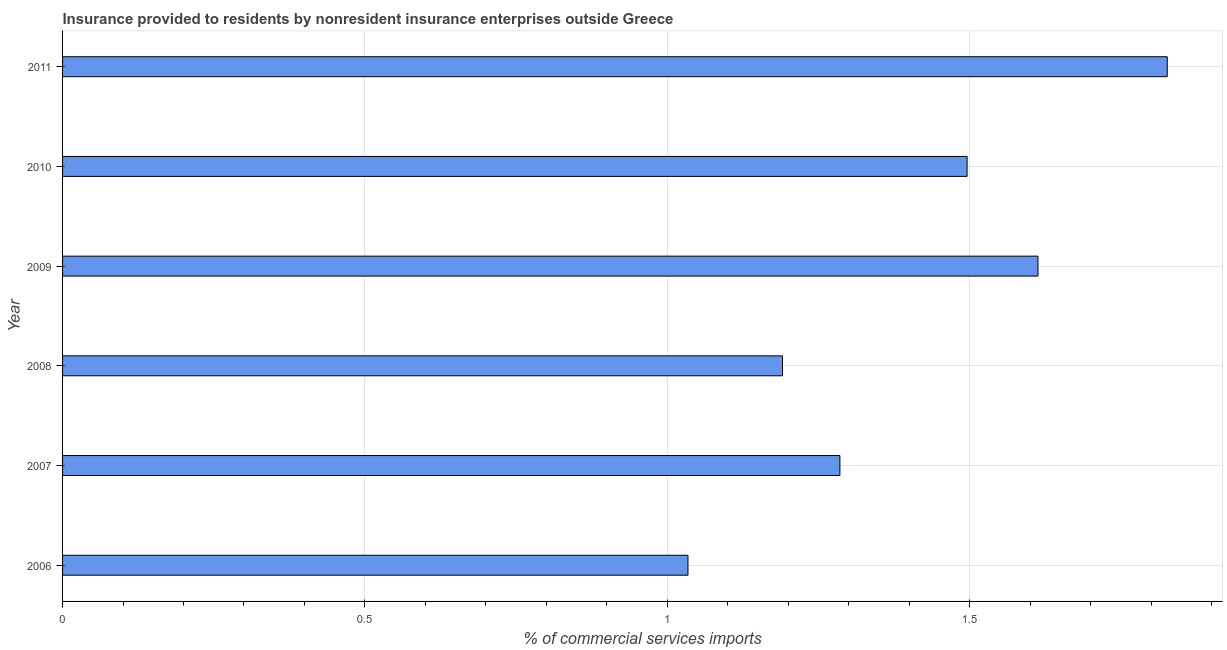What is the title of the graph?
Ensure brevity in your answer.  Insurance provided to residents by nonresident insurance enterprises outside Greece. What is the label or title of the X-axis?
Make the answer very short. % of commercial services imports. What is the insurance provided by non-residents in 2007?
Make the answer very short. 1.29. Across all years, what is the maximum insurance provided by non-residents?
Offer a terse response. 1.83. Across all years, what is the minimum insurance provided by non-residents?
Your answer should be compact. 1.03. In which year was the insurance provided by non-residents maximum?
Provide a succinct answer. 2011. In which year was the insurance provided by non-residents minimum?
Offer a very short reply. 2006. What is the sum of the insurance provided by non-residents?
Give a very brief answer. 8.45. What is the difference between the insurance provided by non-residents in 2007 and 2011?
Offer a very short reply. -0.54. What is the average insurance provided by non-residents per year?
Offer a terse response. 1.41. What is the median insurance provided by non-residents?
Your answer should be very brief. 1.39. What is the ratio of the insurance provided by non-residents in 2008 to that in 2011?
Provide a succinct answer. 0.65. Is the insurance provided by non-residents in 2006 less than that in 2007?
Make the answer very short. Yes. What is the difference between the highest and the second highest insurance provided by non-residents?
Make the answer very short. 0.21. Is the sum of the insurance provided by non-residents in 2007 and 2011 greater than the maximum insurance provided by non-residents across all years?
Your response must be concise. Yes. What is the difference between the highest and the lowest insurance provided by non-residents?
Offer a very short reply. 0.79. In how many years, is the insurance provided by non-residents greater than the average insurance provided by non-residents taken over all years?
Make the answer very short. 3. How many bars are there?
Offer a very short reply. 6. Are all the bars in the graph horizontal?
Provide a short and direct response. Yes. Are the values on the major ticks of X-axis written in scientific E-notation?
Your answer should be very brief. No. What is the % of commercial services imports in 2006?
Offer a very short reply. 1.03. What is the % of commercial services imports of 2007?
Offer a terse response. 1.29. What is the % of commercial services imports of 2008?
Provide a short and direct response. 1.19. What is the % of commercial services imports of 2009?
Make the answer very short. 1.61. What is the % of commercial services imports of 2010?
Ensure brevity in your answer.  1.5. What is the % of commercial services imports of 2011?
Your answer should be compact. 1.83. What is the difference between the % of commercial services imports in 2006 and 2007?
Your answer should be compact. -0.25. What is the difference between the % of commercial services imports in 2006 and 2008?
Make the answer very short. -0.16. What is the difference between the % of commercial services imports in 2006 and 2009?
Keep it short and to the point. -0.58. What is the difference between the % of commercial services imports in 2006 and 2010?
Offer a very short reply. -0.46. What is the difference between the % of commercial services imports in 2006 and 2011?
Your response must be concise. -0.79. What is the difference between the % of commercial services imports in 2007 and 2008?
Ensure brevity in your answer.  0.09. What is the difference between the % of commercial services imports in 2007 and 2009?
Your answer should be very brief. -0.33. What is the difference between the % of commercial services imports in 2007 and 2010?
Make the answer very short. -0.21. What is the difference between the % of commercial services imports in 2007 and 2011?
Make the answer very short. -0.54. What is the difference between the % of commercial services imports in 2008 and 2009?
Ensure brevity in your answer.  -0.42. What is the difference between the % of commercial services imports in 2008 and 2010?
Offer a terse response. -0.31. What is the difference between the % of commercial services imports in 2008 and 2011?
Ensure brevity in your answer.  -0.64. What is the difference between the % of commercial services imports in 2009 and 2010?
Ensure brevity in your answer.  0.12. What is the difference between the % of commercial services imports in 2009 and 2011?
Make the answer very short. -0.21. What is the difference between the % of commercial services imports in 2010 and 2011?
Ensure brevity in your answer.  -0.33. What is the ratio of the % of commercial services imports in 2006 to that in 2007?
Offer a very short reply. 0.81. What is the ratio of the % of commercial services imports in 2006 to that in 2008?
Ensure brevity in your answer.  0.87. What is the ratio of the % of commercial services imports in 2006 to that in 2009?
Give a very brief answer. 0.64. What is the ratio of the % of commercial services imports in 2006 to that in 2010?
Provide a succinct answer. 0.69. What is the ratio of the % of commercial services imports in 2006 to that in 2011?
Make the answer very short. 0.57. What is the ratio of the % of commercial services imports in 2007 to that in 2009?
Provide a succinct answer. 0.8. What is the ratio of the % of commercial services imports in 2007 to that in 2010?
Offer a very short reply. 0.86. What is the ratio of the % of commercial services imports in 2007 to that in 2011?
Give a very brief answer. 0.7. What is the ratio of the % of commercial services imports in 2008 to that in 2009?
Offer a terse response. 0.74. What is the ratio of the % of commercial services imports in 2008 to that in 2010?
Make the answer very short. 0.8. What is the ratio of the % of commercial services imports in 2008 to that in 2011?
Keep it short and to the point. 0.65. What is the ratio of the % of commercial services imports in 2009 to that in 2010?
Make the answer very short. 1.08. What is the ratio of the % of commercial services imports in 2009 to that in 2011?
Make the answer very short. 0.88. What is the ratio of the % of commercial services imports in 2010 to that in 2011?
Provide a short and direct response. 0.82. 